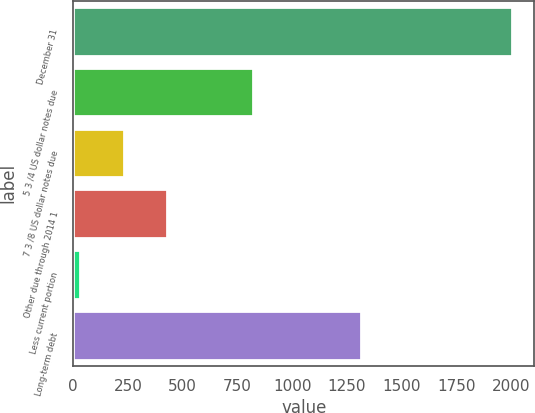Convert chart to OTSL. <chart><loc_0><loc_0><loc_500><loc_500><bar_chart><fcel>December 31<fcel>5 3 /4 US dollar notes due<fcel>7 3 /8 US dollar notes due<fcel>Other due through 2014 1<fcel>Less current portion<fcel>Long-term debt<nl><fcel>2006<fcel>822.2<fcel>230.3<fcel>427.6<fcel>33<fcel>1314<nl></chart> 